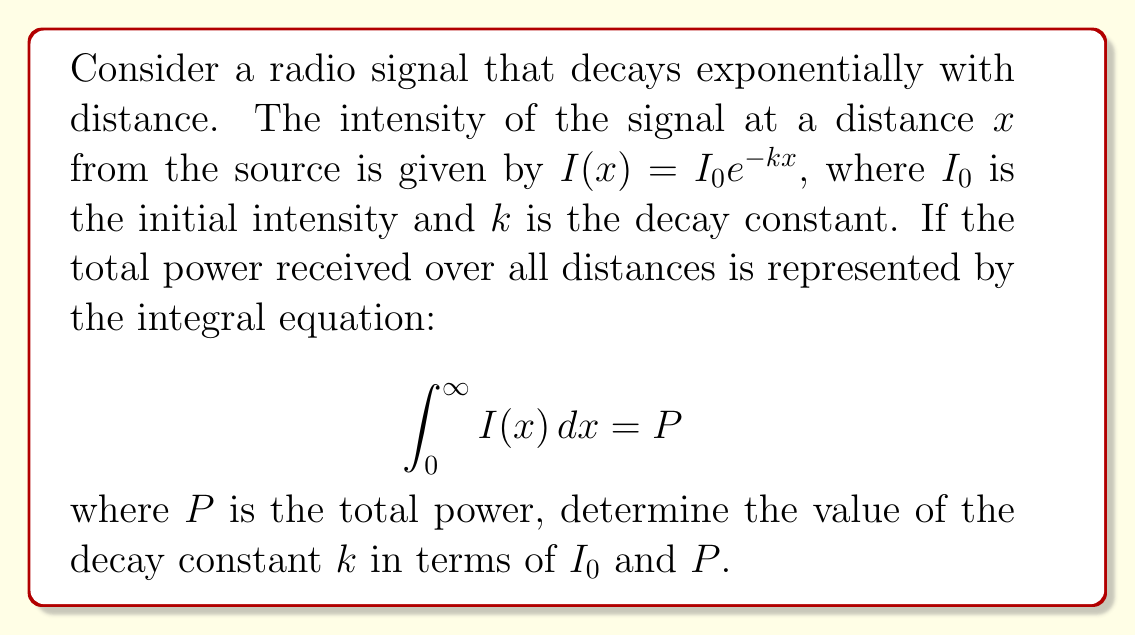Teach me how to tackle this problem. Let's approach this step-by-step:

1) We start with the integral equation:
   $$\int_0^\infty I(x) dx = P$$

2) Substitute the given function for $I(x)$:
   $$\int_0^\infty I_0e^{-kx} dx = P$$

3) Factor out the constant $I_0$:
   $$I_0 \int_0^\infty e^{-kx} dx = P$$

4) To solve this integral, we can use the property of exponential integrals:
   $$\int e^{ax} dx = \frac{1}{a}e^{ax} + C$$

5) Applying this to our integral with $a = -k$:
   $$I_0 \left[-\frac{1}{k}e^{-kx}\right]_0^\infty = P$$

6) Evaluate the integral:
   $$I_0 \left(\lim_{x \to \infty} -\frac{1}{k}e^{-kx} - \left(-\frac{1}{k}e^{-k(0)}\right)\right) = P$$

7) Simplify:
   $$I_0 \left(0 - \left(-\frac{1}{k}\right)\right) = P$$

8) Further simplification:
   $$I_0 \cdot \frac{1}{k} = P$$

9) Solve for $k$:
   $$k = \frac{I_0}{P}$$
Answer: $k = \frac{I_0}{P}$ 